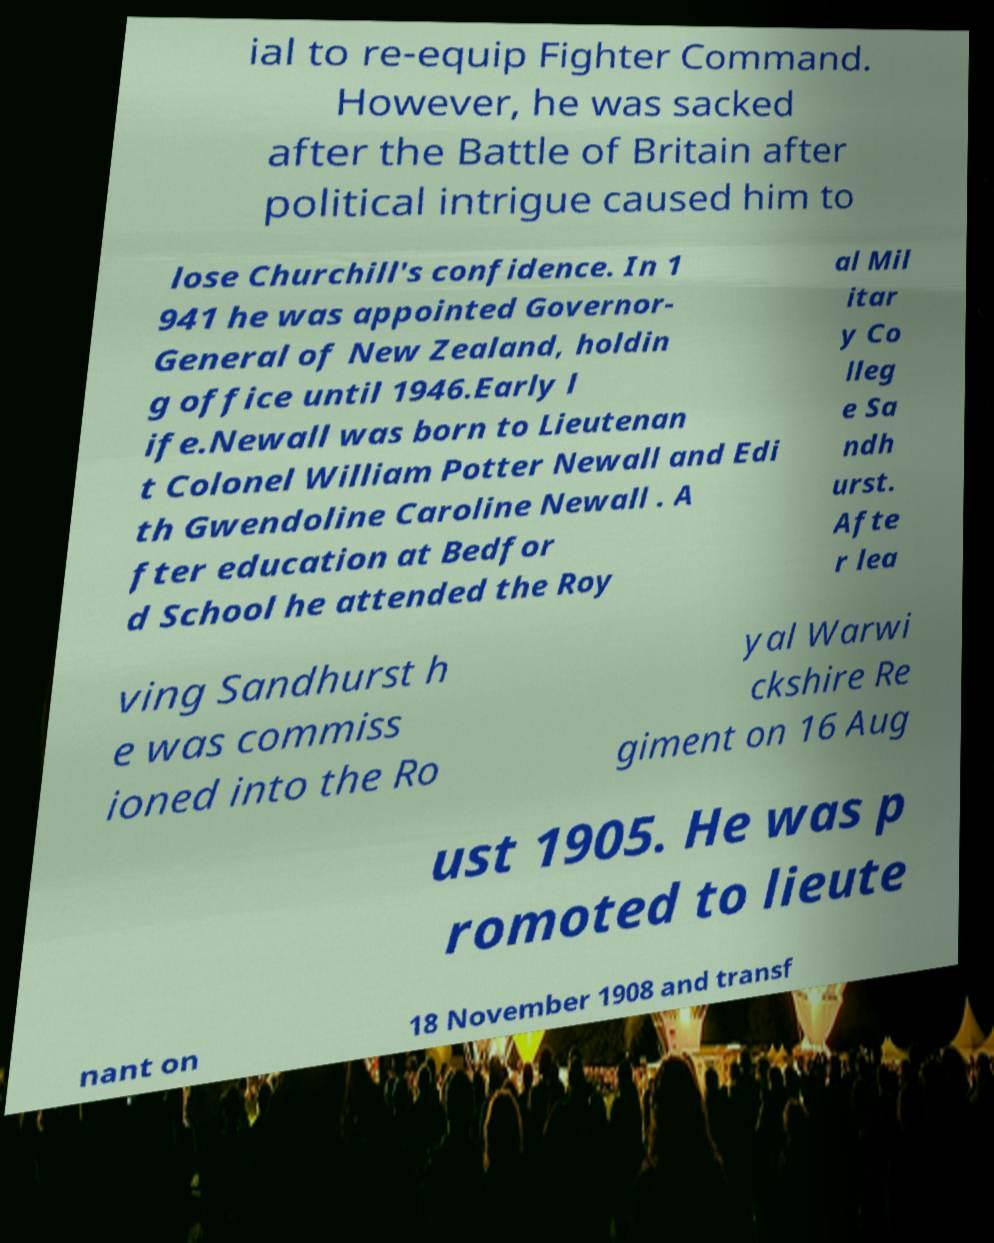Please read and relay the text visible in this image. What does it say? ial to re-equip Fighter Command. However, he was sacked after the Battle of Britain after political intrigue caused him to lose Churchill's confidence. In 1 941 he was appointed Governor- General of New Zealand, holdin g office until 1946.Early l ife.Newall was born to Lieutenan t Colonel William Potter Newall and Edi th Gwendoline Caroline Newall . A fter education at Bedfor d School he attended the Roy al Mil itar y Co lleg e Sa ndh urst. Afte r lea ving Sandhurst h e was commiss ioned into the Ro yal Warwi ckshire Re giment on 16 Aug ust 1905. He was p romoted to lieute nant on 18 November 1908 and transf 